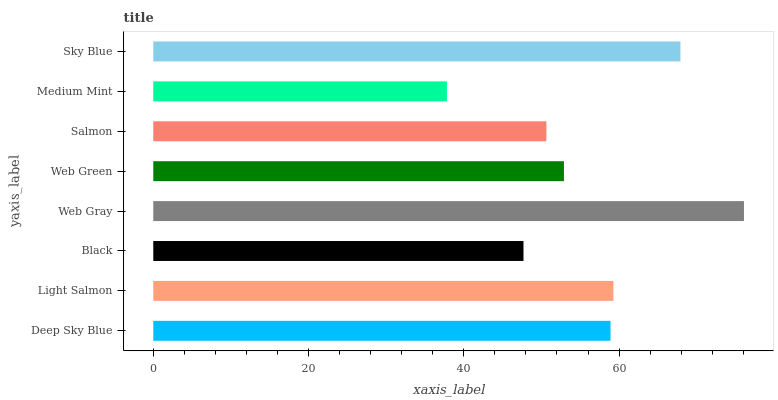Is Medium Mint the minimum?
Answer yes or no. Yes. Is Web Gray the maximum?
Answer yes or no. Yes. Is Light Salmon the minimum?
Answer yes or no. No. Is Light Salmon the maximum?
Answer yes or no. No. Is Light Salmon greater than Deep Sky Blue?
Answer yes or no. Yes. Is Deep Sky Blue less than Light Salmon?
Answer yes or no. Yes. Is Deep Sky Blue greater than Light Salmon?
Answer yes or no. No. Is Light Salmon less than Deep Sky Blue?
Answer yes or no. No. Is Deep Sky Blue the high median?
Answer yes or no. Yes. Is Web Green the low median?
Answer yes or no. Yes. Is Sky Blue the high median?
Answer yes or no. No. Is Deep Sky Blue the low median?
Answer yes or no. No. 